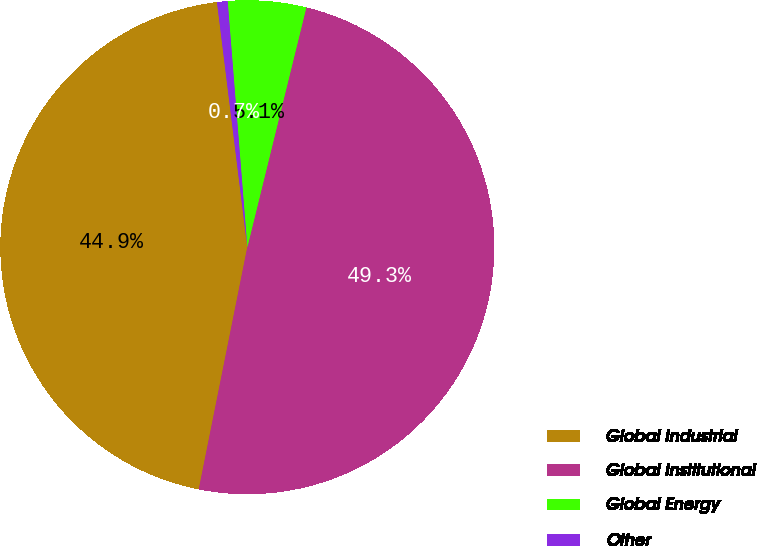<chart> <loc_0><loc_0><loc_500><loc_500><pie_chart><fcel>Global Industrial<fcel>Global Institutional<fcel>Global Energy<fcel>Other<nl><fcel>44.89%<fcel>49.31%<fcel>5.11%<fcel>0.69%<nl></chart> 